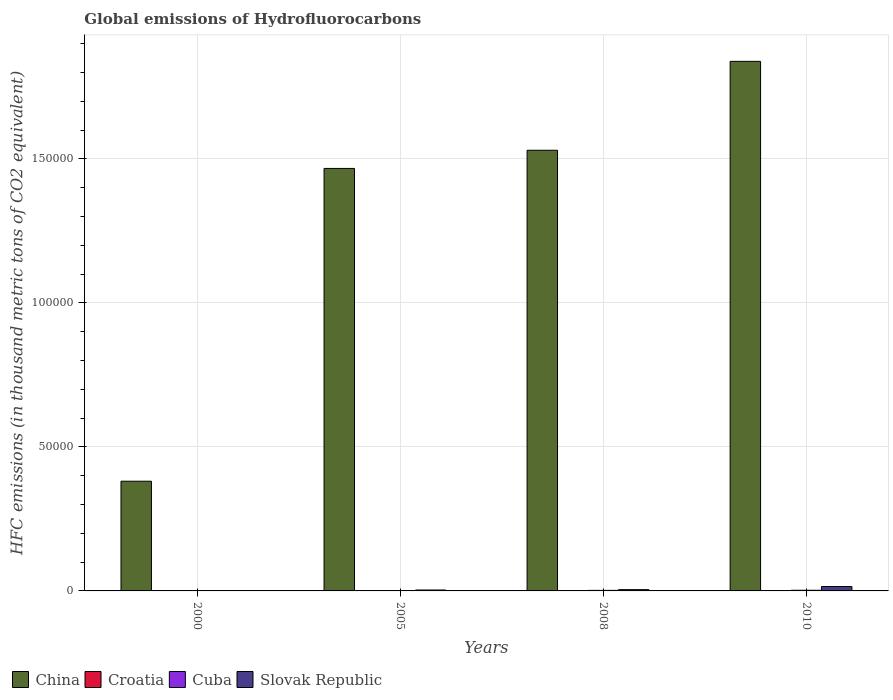How many groups of bars are there?
Offer a very short reply. 4. Are the number of bars per tick equal to the number of legend labels?
Provide a short and direct response. Yes. How many bars are there on the 1st tick from the left?
Provide a succinct answer. 4. What is the label of the 3rd group of bars from the left?
Keep it short and to the point. 2008. In how many cases, is the number of bars for a given year not equal to the number of legend labels?
Make the answer very short. 0. What is the global emissions of Hydrofluorocarbons in China in 2008?
Offer a terse response. 1.53e+05. Across all years, what is the maximum global emissions of Hydrofluorocarbons in Cuba?
Ensure brevity in your answer.  226. In which year was the global emissions of Hydrofluorocarbons in China minimum?
Keep it short and to the point. 2000. What is the total global emissions of Hydrofluorocarbons in Slovak Republic in the graph?
Your response must be concise. 2393.3. What is the difference between the global emissions of Hydrofluorocarbons in Cuba in 2008 and that in 2010?
Your answer should be very brief. -40.1. What is the difference between the global emissions of Hydrofluorocarbons in Slovak Republic in 2010 and the global emissions of Hydrofluorocarbons in Croatia in 2005?
Offer a terse response. 1474.5. What is the average global emissions of Hydrofluorocarbons in Slovak Republic per year?
Provide a succinct answer. 598.33. In the year 2005, what is the difference between the global emissions of Hydrofluorocarbons in China and global emissions of Hydrofluorocarbons in Slovak Republic?
Offer a terse response. 1.46e+05. What is the ratio of the global emissions of Hydrofluorocarbons in Cuba in 2000 to that in 2008?
Keep it short and to the point. 0.18. Is the global emissions of Hydrofluorocarbons in Croatia in 2000 less than that in 2010?
Provide a succinct answer. Yes. Is the difference between the global emissions of Hydrofluorocarbons in China in 2000 and 2008 greater than the difference between the global emissions of Hydrofluorocarbons in Slovak Republic in 2000 and 2008?
Give a very brief answer. No. What is the difference between the highest and the second highest global emissions of Hydrofluorocarbons in China?
Give a very brief answer. 3.09e+04. What is the difference between the highest and the lowest global emissions of Hydrofluorocarbons in Croatia?
Ensure brevity in your answer.  61.7. What does the 1st bar from the right in 2000 represents?
Offer a very short reply. Slovak Republic. Are all the bars in the graph horizontal?
Give a very brief answer. No. Are the values on the major ticks of Y-axis written in scientific E-notation?
Ensure brevity in your answer.  No. Does the graph contain grids?
Ensure brevity in your answer.  Yes. What is the title of the graph?
Your answer should be very brief. Global emissions of Hydrofluorocarbons. What is the label or title of the X-axis?
Provide a short and direct response. Years. What is the label or title of the Y-axis?
Give a very brief answer. HFC emissions (in thousand metric tons of CO2 equivalent). What is the HFC emissions (in thousand metric tons of CO2 equivalent) in China in 2000?
Provide a short and direct response. 3.81e+04. What is the HFC emissions (in thousand metric tons of CO2 equivalent) of Croatia in 2000?
Give a very brief answer. 16.3. What is the HFC emissions (in thousand metric tons of CO2 equivalent) in Cuba in 2000?
Your answer should be compact. 34.2. What is the HFC emissions (in thousand metric tons of CO2 equivalent) of Slovak Republic in 2000?
Provide a short and direct response. 109.3. What is the HFC emissions (in thousand metric tons of CO2 equivalent) in China in 2005?
Your answer should be compact. 1.47e+05. What is the HFC emissions (in thousand metric tons of CO2 equivalent) of Croatia in 2005?
Make the answer very short. 47.5. What is the HFC emissions (in thousand metric tons of CO2 equivalent) in Cuba in 2005?
Your answer should be compact. 127.8. What is the HFC emissions (in thousand metric tons of CO2 equivalent) of Slovak Republic in 2005?
Provide a short and direct response. 319.7. What is the HFC emissions (in thousand metric tons of CO2 equivalent) in China in 2008?
Your response must be concise. 1.53e+05. What is the HFC emissions (in thousand metric tons of CO2 equivalent) in Croatia in 2008?
Provide a short and direct response. 66.3. What is the HFC emissions (in thousand metric tons of CO2 equivalent) in Cuba in 2008?
Offer a terse response. 185.9. What is the HFC emissions (in thousand metric tons of CO2 equivalent) in Slovak Republic in 2008?
Ensure brevity in your answer.  442.3. What is the HFC emissions (in thousand metric tons of CO2 equivalent) in China in 2010?
Your answer should be compact. 1.84e+05. What is the HFC emissions (in thousand metric tons of CO2 equivalent) of Cuba in 2010?
Ensure brevity in your answer.  226. What is the HFC emissions (in thousand metric tons of CO2 equivalent) in Slovak Republic in 2010?
Ensure brevity in your answer.  1522. Across all years, what is the maximum HFC emissions (in thousand metric tons of CO2 equivalent) of China?
Offer a very short reply. 1.84e+05. Across all years, what is the maximum HFC emissions (in thousand metric tons of CO2 equivalent) of Croatia?
Provide a succinct answer. 78. Across all years, what is the maximum HFC emissions (in thousand metric tons of CO2 equivalent) in Cuba?
Keep it short and to the point. 226. Across all years, what is the maximum HFC emissions (in thousand metric tons of CO2 equivalent) of Slovak Republic?
Offer a very short reply. 1522. Across all years, what is the minimum HFC emissions (in thousand metric tons of CO2 equivalent) of China?
Offer a terse response. 3.81e+04. Across all years, what is the minimum HFC emissions (in thousand metric tons of CO2 equivalent) in Croatia?
Give a very brief answer. 16.3. Across all years, what is the minimum HFC emissions (in thousand metric tons of CO2 equivalent) in Cuba?
Offer a very short reply. 34.2. Across all years, what is the minimum HFC emissions (in thousand metric tons of CO2 equivalent) in Slovak Republic?
Provide a succinct answer. 109.3. What is the total HFC emissions (in thousand metric tons of CO2 equivalent) of China in the graph?
Provide a short and direct response. 5.22e+05. What is the total HFC emissions (in thousand metric tons of CO2 equivalent) of Croatia in the graph?
Give a very brief answer. 208.1. What is the total HFC emissions (in thousand metric tons of CO2 equivalent) in Cuba in the graph?
Offer a very short reply. 573.9. What is the total HFC emissions (in thousand metric tons of CO2 equivalent) of Slovak Republic in the graph?
Ensure brevity in your answer.  2393.3. What is the difference between the HFC emissions (in thousand metric tons of CO2 equivalent) of China in 2000 and that in 2005?
Your response must be concise. -1.09e+05. What is the difference between the HFC emissions (in thousand metric tons of CO2 equivalent) in Croatia in 2000 and that in 2005?
Your response must be concise. -31.2. What is the difference between the HFC emissions (in thousand metric tons of CO2 equivalent) of Cuba in 2000 and that in 2005?
Give a very brief answer. -93.6. What is the difference between the HFC emissions (in thousand metric tons of CO2 equivalent) in Slovak Republic in 2000 and that in 2005?
Your answer should be very brief. -210.4. What is the difference between the HFC emissions (in thousand metric tons of CO2 equivalent) in China in 2000 and that in 2008?
Your response must be concise. -1.15e+05. What is the difference between the HFC emissions (in thousand metric tons of CO2 equivalent) in Cuba in 2000 and that in 2008?
Offer a very short reply. -151.7. What is the difference between the HFC emissions (in thousand metric tons of CO2 equivalent) in Slovak Republic in 2000 and that in 2008?
Keep it short and to the point. -333. What is the difference between the HFC emissions (in thousand metric tons of CO2 equivalent) in China in 2000 and that in 2010?
Your response must be concise. -1.46e+05. What is the difference between the HFC emissions (in thousand metric tons of CO2 equivalent) of Croatia in 2000 and that in 2010?
Offer a very short reply. -61.7. What is the difference between the HFC emissions (in thousand metric tons of CO2 equivalent) of Cuba in 2000 and that in 2010?
Provide a short and direct response. -191.8. What is the difference between the HFC emissions (in thousand metric tons of CO2 equivalent) of Slovak Republic in 2000 and that in 2010?
Provide a succinct answer. -1412.7. What is the difference between the HFC emissions (in thousand metric tons of CO2 equivalent) in China in 2005 and that in 2008?
Offer a terse response. -6309. What is the difference between the HFC emissions (in thousand metric tons of CO2 equivalent) of Croatia in 2005 and that in 2008?
Ensure brevity in your answer.  -18.8. What is the difference between the HFC emissions (in thousand metric tons of CO2 equivalent) of Cuba in 2005 and that in 2008?
Give a very brief answer. -58.1. What is the difference between the HFC emissions (in thousand metric tons of CO2 equivalent) of Slovak Republic in 2005 and that in 2008?
Ensure brevity in your answer.  -122.6. What is the difference between the HFC emissions (in thousand metric tons of CO2 equivalent) in China in 2005 and that in 2010?
Make the answer very short. -3.72e+04. What is the difference between the HFC emissions (in thousand metric tons of CO2 equivalent) of Croatia in 2005 and that in 2010?
Your response must be concise. -30.5. What is the difference between the HFC emissions (in thousand metric tons of CO2 equivalent) in Cuba in 2005 and that in 2010?
Your response must be concise. -98.2. What is the difference between the HFC emissions (in thousand metric tons of CO2 equivalent) in Slovak Republic in 2005 and that in 2010?
Offer a terse response. -1202.3. What is the difference between the HFC emissions (in thousand metric tons of CO2 equivalent) in China in 2008 and that in 2010?
Provide a short and direct response. -3.09e+04. What is the difference between the HFC emissions (in thousand metric tons of CO2 equivalent) in Croatia in 2008 and that in 2010?
Ensure brevity in your answer.  -11.7. What is the difference between the HFC emissions (in thousand metric tons of CO2 equivalent) in Cuba in 2008 and that in 2010?
Give a very brief answer. -40.1. What is the difference between the HFC emissions (in thousand metric tons of CO2 equivalent) in Slovak Republic in 2008 and that in 2010?
Your response must be concise. -1079.7. What is the difference between the HFC emissions (in thousand metric tons of CO2 equivalent) in China in 2000 and the HFC emissions (in thousand metric tons of CO2 equivalent) in Croatia in 2005?
Your response must be concise. 3.80e+04. What is the difference between the HFC emissions (in thousand metric tons of CO2 equivalent) in China in 2000 and the HFC emissions (in thousand metric tons of CO2 equivalent) in Cuba in 2005?
Provide a short and direct response. 3.80e+04. What is the difference between the HFC emissions (in thousand metric tons of CO2 equivalent) in China in 2000 and the HFC emissions (in thousand metric tons of CO2 equivalent) in Slovak Republic in 2005?
Your response must be concise. 3.78e+04. What is the difference between the HFC emissions (in thousand metric tons of CO2 equivalent) in Croatia in 2000 and the HFC emissions (in thousand metric tons of CO2 equivalent) in Cuba in 2005?
Provide a succinct answer. -111.5. What is the difference between the HFC emissions (in thousand metric tons of CO2 equivalent) of Croatia in 2000 and the HFC emissions (in thousand metric tons of CO2 equivalent) of Slovak Republic in 2005?
Your answer should be very brief. -303.4. What is the difference between the HFC emissions (in thousand metric tons of CO2 equivalent) of Cuba in 2000 and the HFC emissions (in thousand metric tons of CO2 equivalent) of Slovak Republic in 2005?
Ensure brevity in your answer.  -285.5. What is the difference between the HFC emissions (in thousand metric tons of CO2 equivalent) of China in 2000 and the HFC emissions (in thousand metric tons of CO2 equivalent) of Croatia in 2008?
Your response must be concise. 3.80e+04. What is the difference between the HFC emissions (in thousand metric tons of CO2 equivalent) in China in 2000 and the HFC emissions (in thousand metric tons of CO2 equivalent) in Cuba in 2008?
Your answer should be very brief. 3.79e+04. What is the difference between the HFC emissions (in thousand metric tons of CO2 equivalent) in China in 2000 and the HFC emissions (in thousand metric tons of CO2 equivalent) in Slovak Republic in 2008?
Ensure brevity in your answer.  3.77e+04. What is the difference between the HFC emissions (in thousand metric tons of CO2 equivalent) in Croatia in 2000 and the HFC emissions (in thousand metric tons of CO2 equivalent) in Cuba in 2008?
Your answer should be very brief. -169.6. What is the difference between the HFC emissions (in thousand metric tons of CO2 equivalent) in Croatia in 2000 and the HFC emissions (in thousand metric tons of CO2 equivalent) in Slovak Republic in 2008?
Offer a terse response. -426. What is the difference between the HFC emissions (in thousand metric tons of CO2 equivalent) in Cuba in 2000 and the HFC emissions (in thousand metric tons of CO2 equivalent) in Slovak Republic in 2008?
Your answer should be very brief. -408.1. What is the difference between the HFC emissions (in thousand metric tons of CO2 equivalent) in China in 2000 and the HFC emissions (in thousand metric tons of CO2 equivalent) in Croatia in 2010?
Give a very brief answer. 3.80e+04. What is the difference between the HFC emissions (in thousand metric tons of CO2 equivalent) in China in 2000 and the HFC emissions (in thousand metric tons of CO2 equivalent) in Cuba in 2010?
Give a very brief answer. 3.79e+04. What is the difference between the HFC emissions (in thousand metric tons of CO2 equivalent) of China in 2000 and the HFC emissions (in thousand metric tons of CO2 equivalent) of Slovak Republic in 2010?
Your answer should be compact. 3.66e+04. What is the difference between the HFC emissions (in thousand metric tons of CO2 equivalent) in Croatia in 2000 and the HFC emissions (in thousand metric tons of CO2 equivalent) in Cuba in 2010?
Give a very brief answer. -209.7. What is the difference between the HFC emissions (in thousand metric tons of CO2 equivalent) of Croatia in 2000 and the HFC emissions (in thousand metric tons of CO2 equivalent) of Slovak Republic in 2010?
Your answer should be very brief. -1505.7. What is the difference between the HFC emissions (in thousand metric tons of CO2 equivalent) in Cuba in 2000 and the HFC emissions (in thousand metric tons of CO2 equivalent) in Slovak Republic in 2010?
Provide a succinct answer. -1487.8. What is the difference between the HFC emissions (in thousand metric tons of CO2 equivalent) in China in 2005 and the HFC emissions (in thousand metric tons of CO2 equivalent) in Croatia in 2008?
Provide a short and direct response. 1.47e+05. What is the difference between the HFC emissions (in thousand metric tons of CO2 equivalent) of China in 2005 and the HFC emissions (in thousand metric tons of CO2 equivalent) of Cuba in 2008?
Provide a succinct answer. 1.47e+05. What is the difference between the HFC emissions (in thousand metric tons of CO2 equivalent) in China in 2005 and the HFC emissions (in thousand metric tons of CO2 equivalent) in Slovak Republic in 2008?
Your answer should be compact. 1.46e+05. What is the difference between the HFC emissions (in thousand metric tons of CO2 equivalent) of Croatia in 2005 and the HFC emissions (in thousand metric tons of CO2 equivalent) of Cuba in 2008?
Your answer should be compact. -138.4. What is the difference between the HFC emissions (in thousand metric tons of CO2 equivalent) of Croatia in 2005 and the HFC emissions (in thousand metric tons of CO2 equivalent) of Slovak Republic in 2008?
Offer a terse response. -394.8. What is the difference between the HFC emissions (in thousand metric tons of CO2 equivalent) of Cuba in 2005 and the HFC emissions (in thousand metric tons of CO2 equivalent) of Slovak Republic in 2008?
Offer a terse response. -314.5. What is the difference between the HFC emissions (in thousand metric tons of CO2 equivalent) of China in 2005 and the HFC emissions (in thousand metric tons of CO2 equivalent) of Croatia in 2010?
Your response must be concise. 1.47e+05. What is the difference between the HFC emissions (in thousand metric tons of CO2 equivalent) of China in 2005 and the HFC emissions (in thousand metric tons of CO2 equivalent) of Cuba in 2010?
Your response must be concise. 1.46e+05. What is the difference between the HFC emissions (in thousand metric tons of CO2 equivalent) in China in 2005 and the HFC emissions (in thousand metric tons of CO2 equivalent) in Slovak Republic in 2010?
Your answer should be compact. 1.45e+05. What is the difference between the HFC emissions (in thousand metric tons of CO2 equivalent) of Croatia in 2005 and the HFC emissions (in thousand metric tons of CO2 equivalent) of Cuba in 2010?
Your answer should be very brief. -178.5. What is the difference between the HFC emissions (in thousand metric tons of CO2 equivalent) in Croatia in 2005 and the HFC emissions (in thousand metric tons of CO2 equivalent) in Slovak Republic in 2010?
Your answer should be very brief. -1474.5. What is the difference between the HFC emissions (in thousand metric tons of CO2 equivalent) of Cuba in 2005 and the HFC emissions (in thousand metric tons of CO2 equivalent) of Slovak Republic in 2010?
Make the answer very short. -1394.2. What is the difference between the HFC emissions (in thousand metric tons of CO2 equivalent) of China in 2008 and the HFC emissions (in thousand metric tons of CO2 equivalent) of Croatia in 2010?
Provide a succinct answer. 1.53e+05. What is the difference between the HFC emissions (in thousand metric tons of CO2 equivalent) of China in 2008 and the HFC emissions (in thousand metric tons of CO2 equivalent) of Cuba in 2010?
Provide a short and direct response. 1.53e+05. What is the difference between the HFC emissions (in thousand metric tons of CO2 equivalent) of China in 2008 and the HFC emissions (in thousand metric tons of CO2 equivalent) of Slovak Republic in 2010?
Provide a short and direct response. 1.51e+05. What is the difference between the HFC emissions (in thousand metric tons of CO2 equivalent) in Croatia in 2008 and the HFC emissions (in thousand metric tons of CO2 equivalent) in Cuba in 2010?
Keep it short and to the point. -159.7. What is the difference between the HFC emissions (in thousand metric tons of CO2 equivalent) in Croatia in 2008 and the HFC emissions (in thousand metric tons of CO2 equivalent) in Slovak Republic in 2010?
Provide a succinct answer. -1455.7. What is the difference between the HFC emissions (in thousand metric tons of CO2 equivalent) in Cuba in 2008 and the HFC emissions (in thousand metric tons of CO2 equivalent) in Slovak Republic in 2010?
Make the answer very short. -1336.1. What is the average HFC emissions (in thousand metric tons of CO2 equivalent) in China per year?
Keep it short and to the point. 1.30e+05. What is the average HFC emissions (in thousand metric tons of CO2 equivalent) in Croatia per year?
Your answer should be compact. 52.02. What is the average HFC emissions (in thousand metric tons of CO2 equivalent) in Cuba per year?
Your answer should be very brief. 143.47. What is the average HFC emissions (in thousand metric tons of CO2 equivalent) in Slovak Republic per year?
Ensure brevity in your answer.  598.33. In the year 2000, what is the difference between the HFC emissions (in thousand metric tons of CO2 equivalent) in China and HFC emissions (in thousand metric tons of CO2 equivalent) in Croatia?
Keep it short and to the point. 3.81e+04. In the year 2000, what is the difference between the HFC emissions (in thousand metric tons of CO2 equivalent) in China and HFC emissions (in thousand metric tons of CO2 equivalent) in Cuba?
Offer a very short reply. 3.81e+04. In the year 2000, what is the difference between the HFC emissions (in thousand metric tons of CO2 equivalent) of China and HFC emissions (in thousand metric tons of CO2 equivalent) of Slovak Republic?
Keep it short and to the point. 3.80e+04. In the year 2000, what is the difference between the HFC emissions (in thousand metric tons of CO2 equivalent) in Croatia and HFC emissions (in thousand metric tons of CO2 equivalent) in Cuba?
Provide a succinct answer. -17.9. In the year 2000, what is the difference between the HFC emissions (in thousand metric tons of CO2 equivalent) in Croatia and HFC emissions (in thousand metric tons of CO2 equivalent) in Slovak Republic?
Provide a succinct answer. -93. In the year 2000, what is the difference between the HFC emissions (in thousand metric tons of CO2 equivalent) of Cuba and HFC emissions (in thousand metric tons of CO2 equivalent) of Slovak Republic?
Offer a terse response. -75.1. In the year 2005, what is the difference between the HFC emissions (in thousand metric tons of CO2 equivalent) in China and HFC emissions (in thousand metric tons of CO2 equivalent) in Croatia?
Offer a very short reply. 1.47e+05. In the year 2005, what is the difference between the HFC emissions (in thousand metric tons of CO2 equivalent) of China and HFC emissions (in thousand metric tons of CO2 equivalent) of Cuba?
Provide a short and direct response. 1.47e+05. In the year 2005, what is the difference between the HFC emissions (in thousand metric tons of CO2 equivalent) of China and HFC emissions (in thousand metric tons of CO2 equivalent) of Slovak Republic?
Offer a terse response. 1.46e+05. In the year 2005, what is the difference between the HFC emissions (in thousand metric tons of CO2 equivalent) in Croatia and HFC emissions (in thousand metric tons of CO2 equivalent) in Cuba?
Offer a terse response. -80.3. In the year 2005, what is the difference between the HFC emissions (in thousand metric tons of CO2 equivalent) in Croatia and HFC emissions (in thousand metric tons of CO2 equivalent) in Slovak Republic?
Offer a very short reply. -272.2. In the year 2005, what is the difference between the HFC emissions (in thousand metric tons of CO2 equivalent) of Cuba and HFC emissions (in thousand metric tons of CO2 equivalent) of Slovak Republic?
Your answer should be compact. -191.9. In the year 2008, what is the difference between the HFC emissions (in thousand metric tons of CO2 equivalent) in China and HFC emissions (in thousand metric tons of CO2 equivalent) in Croatia?
Your answer should be very brief. 1.53e+05. In the year 2008, what is the difference between the HFC emissions (in thousand metric tons of CO2 equivalent) in China and HFC emissions (in thousand metric tons of CO2 equivalent) in Cuba?
Give a very brief answer. 1.53e+05. In the year 2008, what is the difference between the HFC emissions (in thousand metric tons of CO2 equivalent) of China and HFC emissions (in thousand metric tons of CO2 equivalent) of Slovak Republic?
Keep it short and to the point. 1.53e+05. In the year 2008, what is the difference between the HFC emissions (in thousand metric tons of CO2 equivalent) of Croatia and HFC emissions (in thousand metric tons of CO2 equivalent) of Cuba?
Offer a terse response. -119.6. In the year 2008, what is the difference between the HFC emissions (in thousand metric tons of CO2 equivalent) of Croatia and HFC emissions (in thousand metric tons of CO2 equivalent) of Slovak Republic?
Make the answer very short. -376. In the year 2008, what is the difference between the HFC emissions (in thousand metric tons of CO2 equivalent) in Cuba and HFC emissions (in thousand metric tons of CO2 equivalent) in Slovak Republic?
Your answer should be very brief. -256.4. In the year 2010, what is the difference between the HFC emissions (in thousand metric tons of CO2 equivalent) in China and HFC emissions (in thousand metric tons of CO2 equivalent) in Croatia?
Give a very brief answer. 1.84e+05. In the year 2010, what is the difference between the HFC emissions (in thousand metric tons of CO2 equivalent) in China and HFC emissions (in thousand metric tons of CO2 equivalent) in Cuba?
Your answer should be very brief. 1.84e+05. In the year 2010, what is the difference between the HFC emissions (in thousand metric tons of CO2 equivalent) in China and HFC emissions (in thousand metric tons of CO2 equivalent) in Slovak Republic?
Make the answer very short. 1.82e+05. In the year 2010, what is the difference between the HFC emissions (in thousand metric tons of CO2 equivalent) of Croatia and HFC emissions (in thousand metric tons of CO2 equivalent) of Cuba?
Your answer should be compact. -148. In the year 2010, what is the difference between the HFC emissions (in thousand metric tons of CO2 equivalent) in Croatia and HFC emissions (in thousand metric tons of CO2 equivalent) in Slovak Republic?
Your response must be concise. -1444. In the year 2010, what is the difference between the HFC emissions (in thousand metric tons of CO2 equivalent) in Cuba and HFC emissions (in thousand metric tons of CO2 equivalent) in Slovak Republic?
Offer a terse response. -1296. What is the ratio of the HFC emissions (in thousand metric tons of CO2 equivalent) of China in 2000 to that in 2005?
Keep it short and to the point. 0.26. What is the ratio of the HFC emissions (in thousand metric tons of CO2 equivalent) of Croatia in 2000 to that in 2005?
Make the answer very short. 0.34. What is the ratio of the HFC emissions (in thousand metric tons of CO2 equivalent) in Cuba in 2000 to that in 2005?
Offer a terse response. 0.27. What is the ratio of the HFC emissions (in thousand metric tons of CO2 equivalent) in Slovak Republic in 2000 to that in 2005?
Your answer should be compact. 0.34. What is the ratio of the HFC emissions (in thousand metric tons of CO2 equivalent) in China in 2000 to that in 2008?
Give a very brief answer. 0.25. What is the ratio of the HFC emissions (in thousand metric tons of CO2 equivalent) of Croatia in 2000 to that in 2008?
Ensure brevity in your answer.  0.25. What is the ratio of the HFC emissions (in thousand metric tons of CO2 equivalent) of Cuba in 2000 to that in 2008?
Ensure brevity in your answer.  0.18. What is the ratio of the HFC emissions (in thousand metric tons of CO2 equivalent) in Slovak Republic in 2000 to that in 2008?
Offer a terse response. 0.25. What is the ratio of the HFC emissions (in thousand metric tons of CO2 equivalent) of China in 2000 to that in 2010?
Make the answer very short. 0.21. What is the ratio of the HFC emissions (in thousand metric tons of CO2 equivalent) of Croatia in 2000 to that in 2010?
Ensure brevity in your answer.  0.21. What is the ratio of the HFC emissions (in thousand metric tons of CO2 equivalent) in Cuba in 2000 to that in 2010?
Make the answer very short. 0.15. What is the ratio of the HFC emissions (in thousand metric tons of CO2 equivalent) in Slovak Republic in 2000 to that in 2010?
Provide a succinct answer. 0.07. What is the ratio of the HFC emissions (in thousand metric tons of CO2 equivalent) in China in 2005 to that in 2008?
Your answer should be compact. 0.96. What is the ratio of the HFC emissions (in thousand metric tons of CO2 equivalent) of Croatia in 2005 to that in 2008?
Your response must be concise. 0.72. What is the ratio of the HFC emissions (in thousand metric tons of CO2 equivalent) in Cuba in 2005 to that in 2008?
Your response must be concise. 0.69. What is the ratio of the HFC emissions (in thousand metric tons of CO2 equivalent) in Slovak Republic in 2005 to that in 2008?
Provide a succinct answer. 0.72. What is the ratio of the HFC emissions (in thousand metric tons of CO2 equivalent) in China in 2005 to that in 2010?
Offer a very short reply. 0.8. What is the ratio of the HFC emissions (in thousand metric tons of CO2 equivalent) of Croatia in 2005 to that in 2010?
Ensure brevity in your answer.  0.61. What is the ratio of the HFC emissions (in thousand metric tons of CO2 equivalent) of Cuba in 2005 to that in 2010?
Offer a terse response. 0.57. What is the ratio of the HFC emissions (in thousand metric tons of CO2 equivalent) in Slovak Republic in 2005 to that in 2010?
Your response must be concise. 0.21. What is the ratio of the HFC emissions (in thousand metric tons of CO2 equivalent) of China in 2008 to that in 2010?
Provide a short and direct response. 0.83. What is the ratio of the HFC emissions (in thousand metric tons of CO2 equivalent) in Croatia in 2008 to that in 2010?
Make the answer very short. 0.85. What is the ratio of the HFC emissions (in thousand metric tons of CO2 equivalent) of Cuba in 2008 to that in 2010?
Provide a succinct answer. 0.82. What is the ratio of the HFC emissions (in thousand metric tons of CO2 equivalent) of Slovak Republic in 2008 to that in 2010?
Give a very brief answer. 0.29. What is the difference between the highest and the second highest HFC emissions (in thousand metric tons of CO2 equivalent) of China?
Give a very brief answer. 3.09e+04. What is the difference between the highest and the second highest HFC emissions (in thousand metric tons of CO2 equivalent) of Cuba?
Offer a terse response. 40.1. What is the difference between the highest and the second highest HFC emissions (in thousand metric tons of CO2 equivalent) of Slovak Republic?
Your answer should be very brief. 1079.7. What is the difference between the highest and the lowest HFC emissions (in thousand metric tons of CO2 equivalent) of China?
Keep it short and to the point. 1.46e+05. What is the difference between the highest and the lowest HFC emissions (in thousand metric tons of CO2 equivalent) of Croatia?
Offer a terse response. 61.7. What is the difference between the highest and the lowest HFC emissions (in thousand metric tons of CO2 equivalent) of Cuba?
Keep it short and to the point. 191.8. What is the difference between the highest and the lowest HFC emissions (in thousand metric tons of CO2 equivalent) in Slovak Republic?
Provide a succinct answer. 1412.7. 